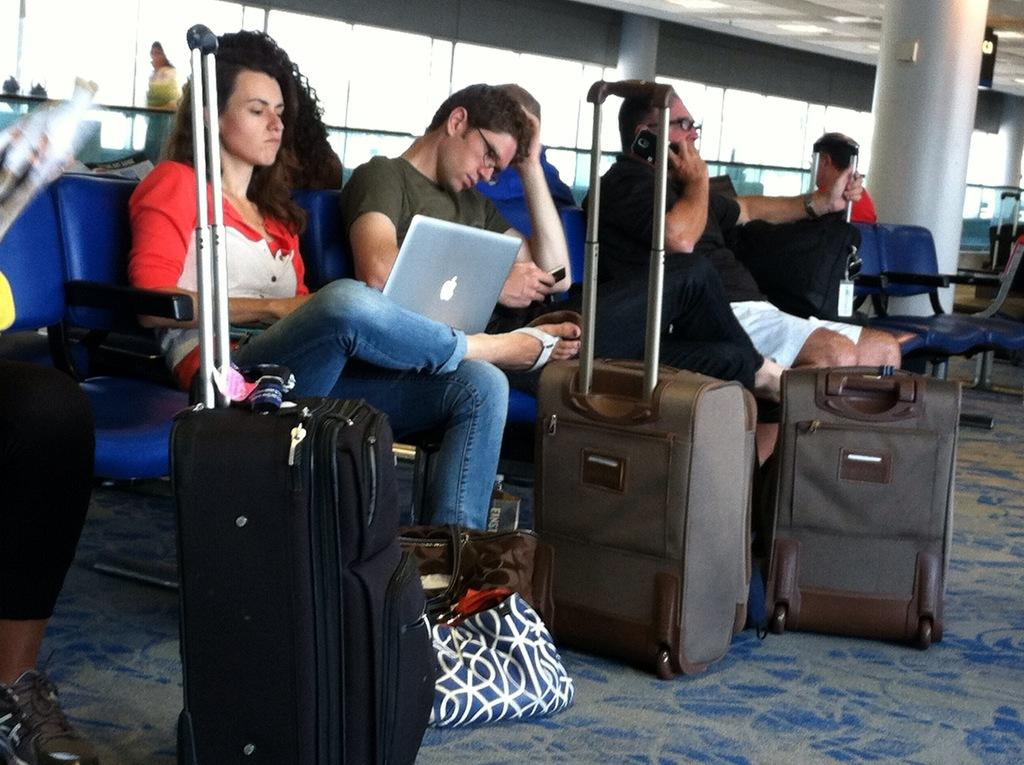How many people are in the image? There is a group of people in the image, but the exact number is not specified. What are the people doing in the image? The people are sitting on seats in the image. What items can be seen that might be used for carrying belongings? There are suitcases and bags in the image. What electronic device is visible in the image? There is a laptop in the image. What architectural features can be seen in the background of the image? There is a pillar, windows, and a fence in the background of the image. What type of orange is being used as a basket in the image? There is no orange or basket present in the image. 